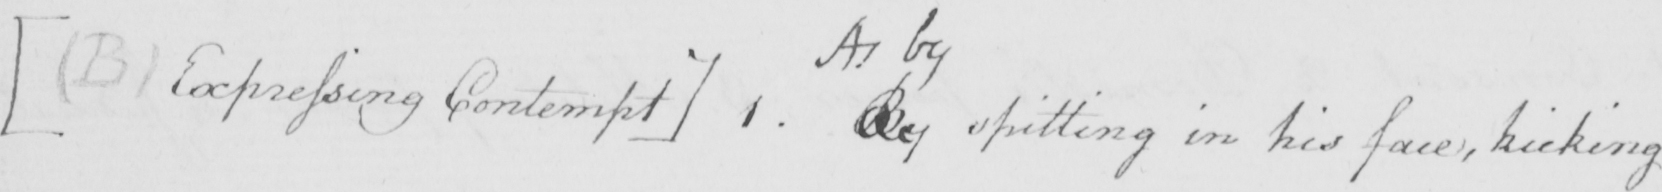What does this handwritten line say? [  ( B )  Expressing Contempt . ] 1 . By spitting in his face , kicking 